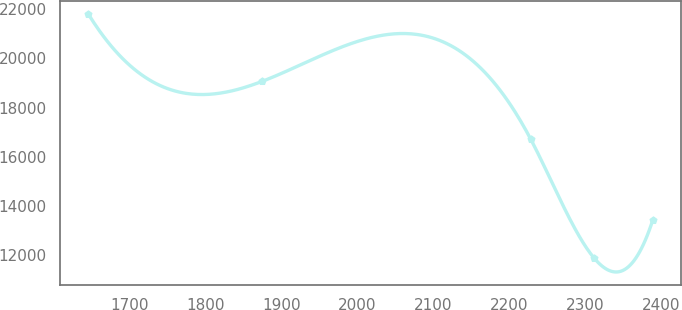Convert chart to OTSL. <chart><loc_0><loc_0><loc_500><loc_500><line_chart><ecel><fcel>Unnamed: 1<nl><fcel>1646.12<fcel>21805.7<nl><fcel>1875.17<fcel>19070.7<nl><fcel>2227.94<fcel>16723.5<nl><fcel>2311.25<fcel>11875.2<nl><fcel>2388.82<fcel>13417.7<nl></chart> 